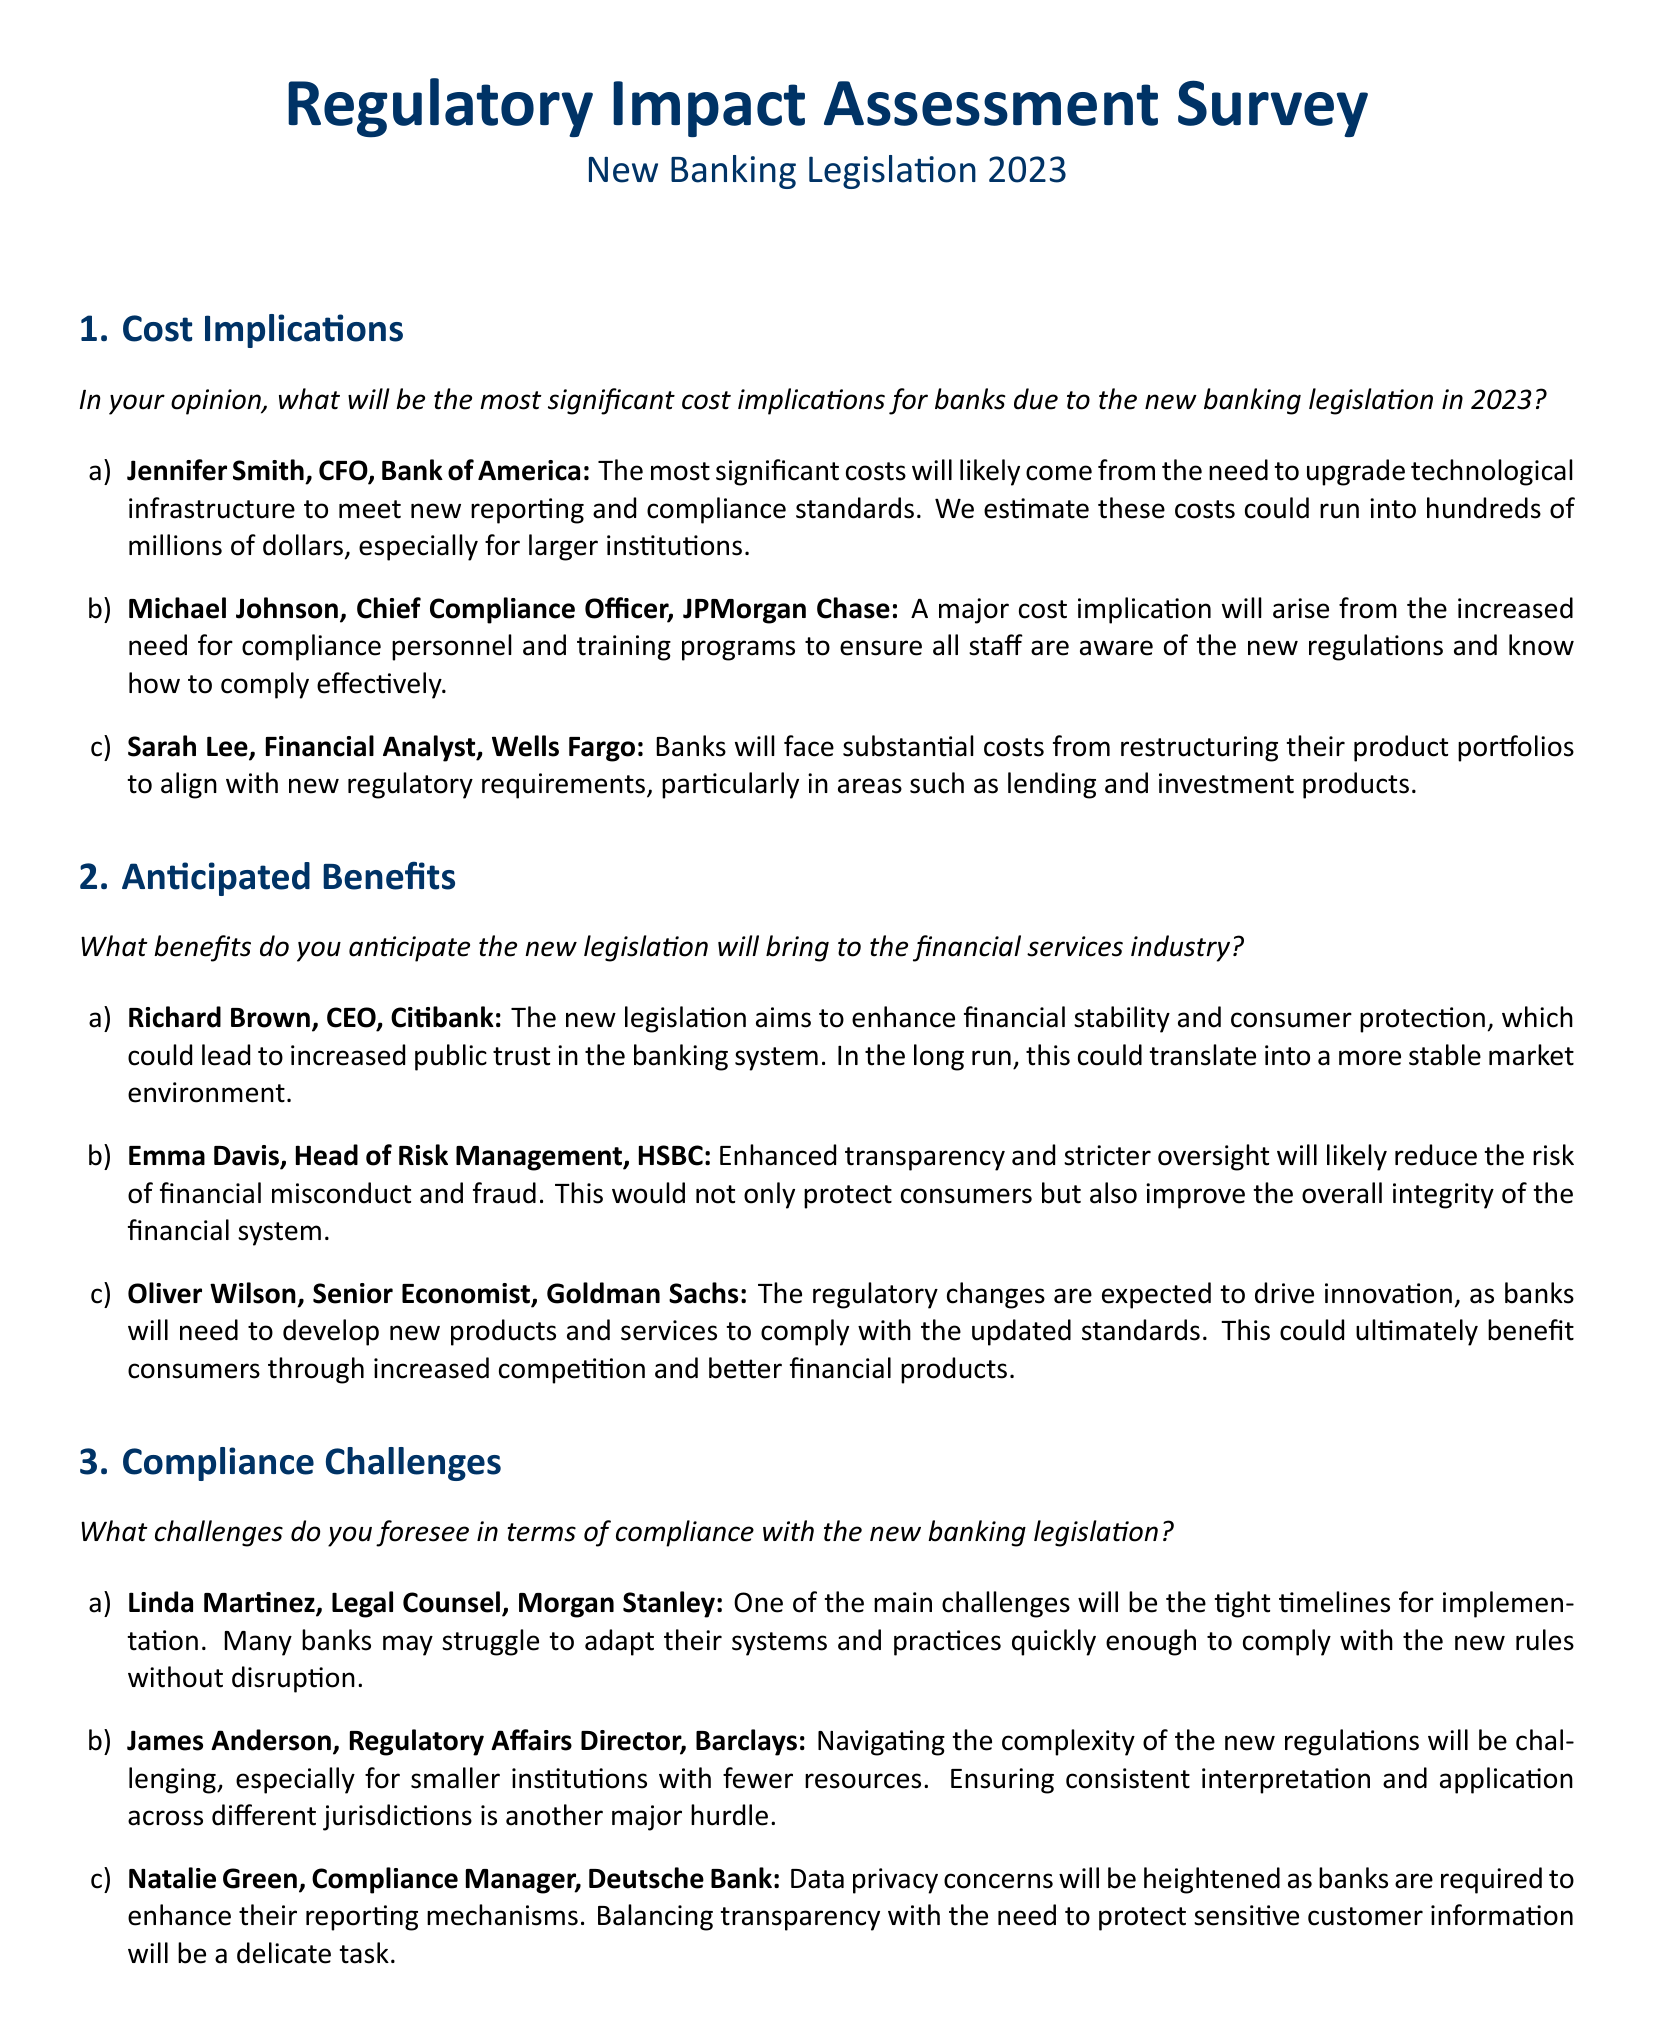What is the most significant cost implication mentioned by Jennifer Smith? Jennifer Smith states that the most significant costs will come from upgrading technological infrastructure.
Answer: Upgrading technological infrastructure What benefit does Richard Brown anticipate from the new legislation? Richard Brown believes the new legislation will enhance financial stability and consumer protection.
Answer: Enhanced financial stability and consumer protection Who highlighted the challenge of tight implementation timelines? Linda Martinez identified tight timelines for implementation as a major compliance challenge.
Answer: Linda Martinez What was the estimated cost of compliance upgrades mentioned by Jennifer Smith? Jennifer Smith estimates that costs could run into hundreds of millions of dollars for compliance upgrades.
Answer: Hundreds of millions of dollars Which institution does James Anderson represent? James Anderson is the Regulatory Affairs Director at Barclays.
Answer: Barclays What challenge related to data is mentioned by Natalie Green? Natalie Green mentions heightened data privacy concerns due to enhanced reporting requirements.
Answer: Heightened data privacy concerns What type of professionals did Michael Johnson say will be needed in greater numbers? Michael Johnson indicated that there will be an increased need for compliance personnel.
Answer: Compliance personnel How many professionals were quoted in the survey for costs? Three professionals were quoted regarding the cost implications.
Answer: Three What type of oversight does Emma Davis believe will reduce financial misconduct? Emma Davis emphasizes that enhanced transparency and stricter oversight will help mitigate misconduct.
Answer: Enhanced transparency and stricter oversight 